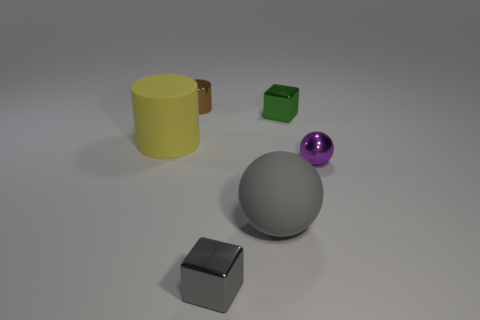Add 4 large rubber cylinders. How many objects exist? 10 Subtract all balls. How many objects are left? 4 Subtract 0 blue spheres. How many objects are left? 6 Subtract all red cylinders. Subtract all small metal cylinders. How many objects are left? 5 Add 4 matte cylinders. How many matte cylinders are left? 5 Add 2 blocks. How many blocks exist? 4 